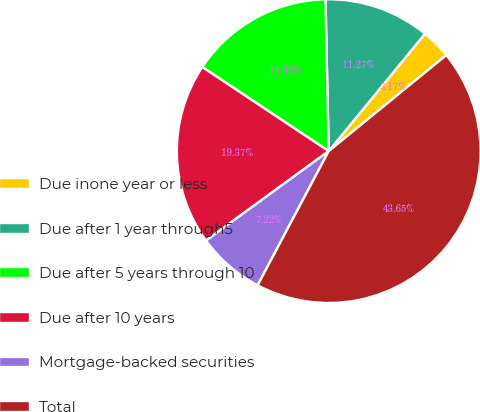Convert chart. <chart><loc_0><loc_0><loc_500><loc_500><pie_chart><fcel>Due inone year or less<fcel>Due after 1 year through5<fcel>Due after 5 years through 10<fcel>Due after 10 years<fcel>Mortgage-backed securities<fcel>Total<nl><fcel>3.17%<fcel>11.27%<fcel>15.32%<fcel>19.37%<fcel>7.22%<fcel>43.65%<nl></chart> 